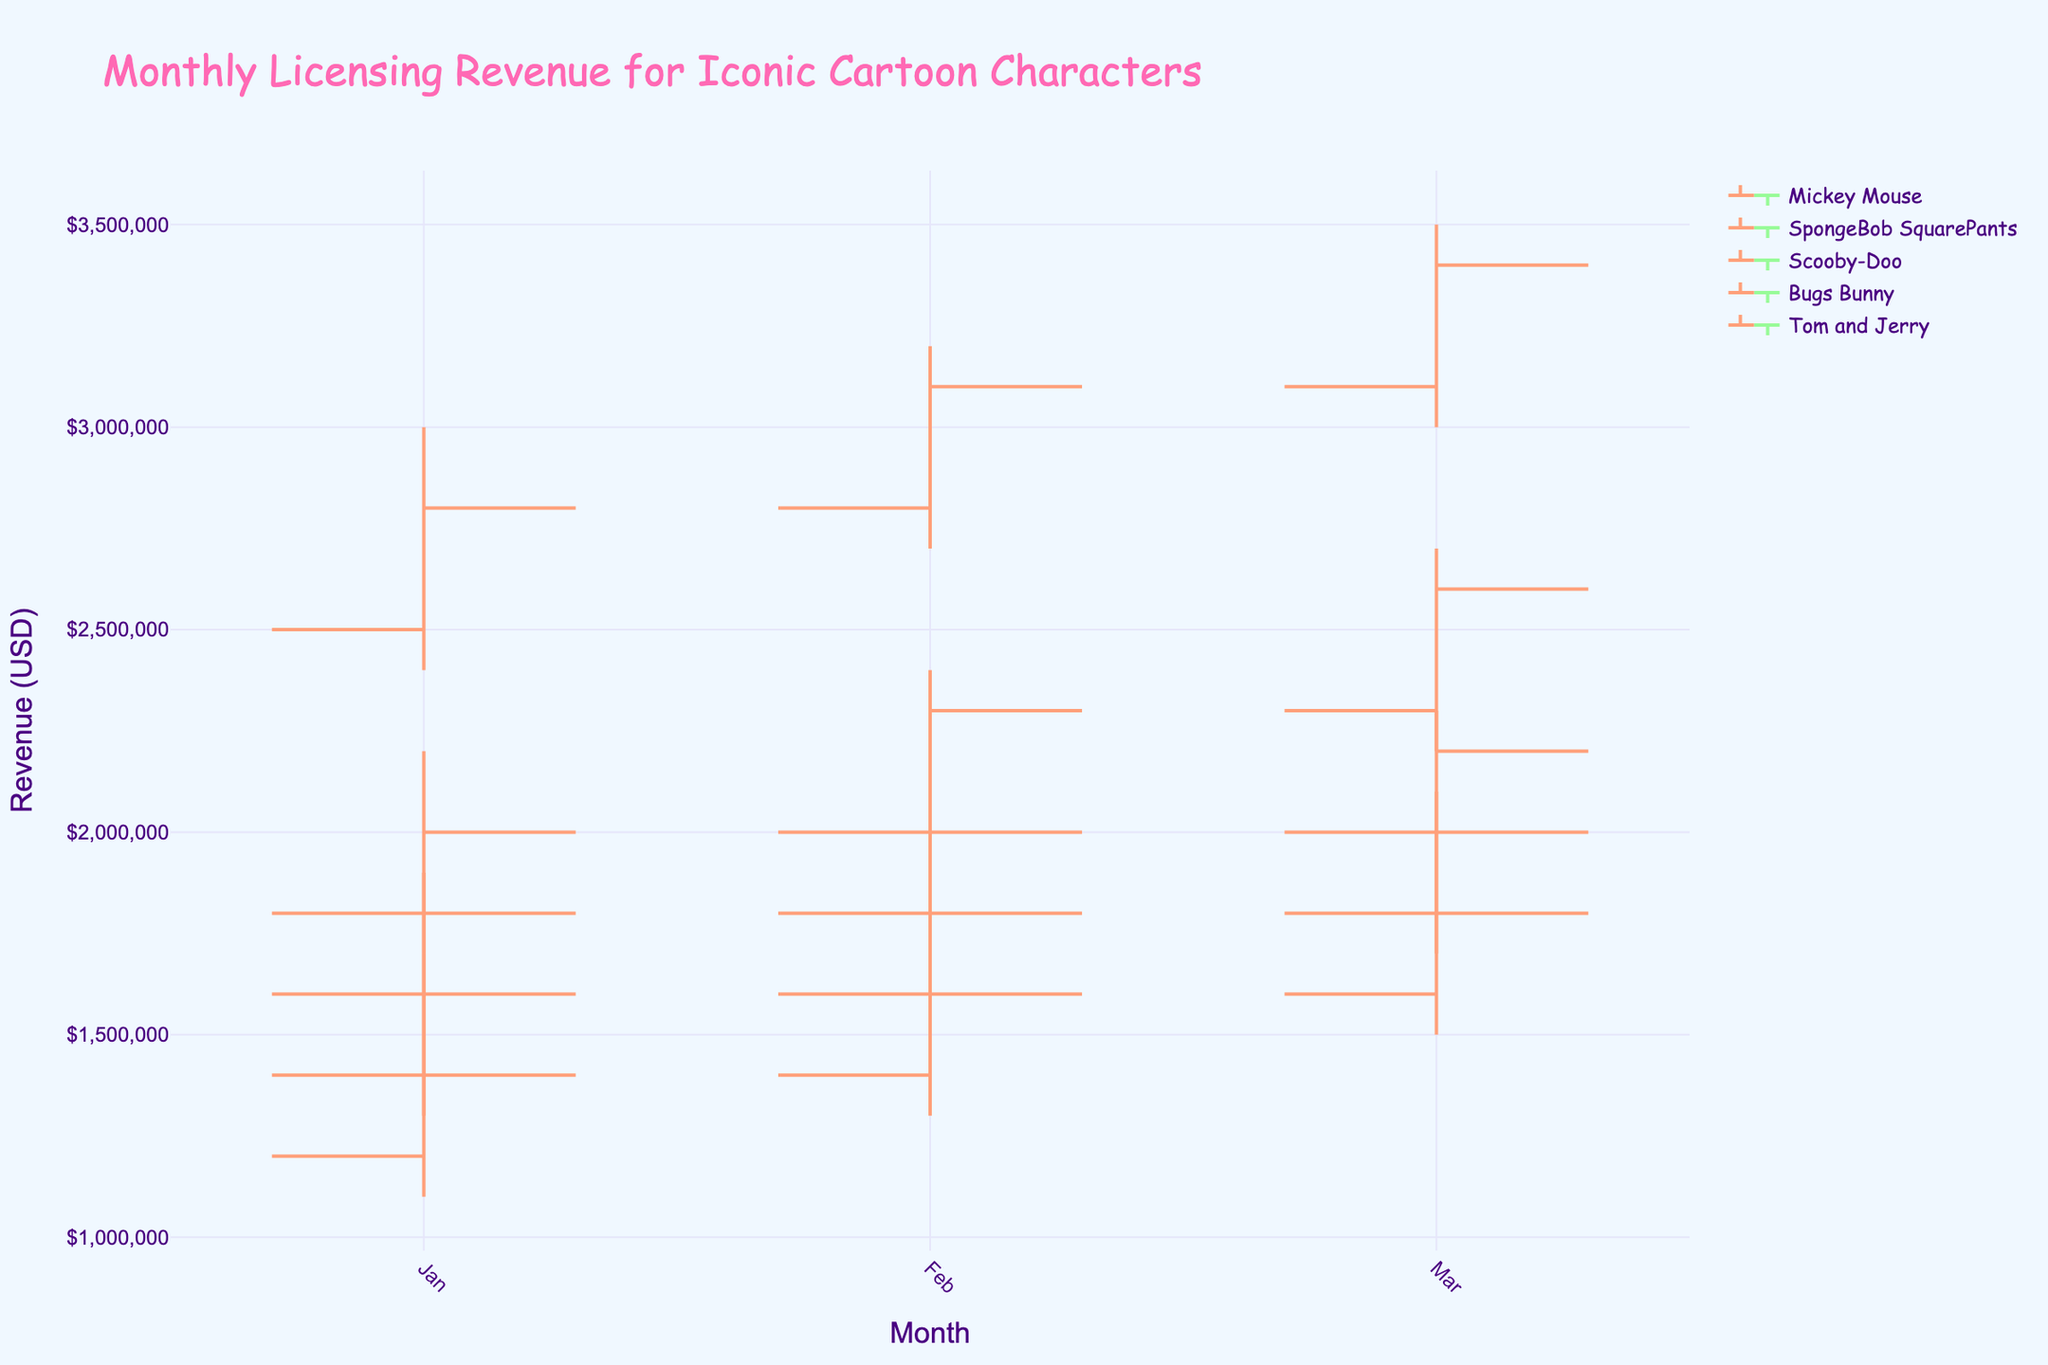What's the title of the figure? The title is usually located at the top of the figure and is explicitly displayed.
Answer: Monthly Licensing Revenue for Iconic Cartoon Characters Which character had the highest closing revenue in March? By looking at the 'Close' value for each character in March, identify the highest value among them.
Answer: Mickey Mouse What is the color used for increasing lines in the chart? Inspect the color of lines when the closing value is higher than the opening value.
Answer: Light Salmon Which character had the lowest low in February? Examine the 'Low' values for each character in February and determine which one is the lowest.
Answer: Scooby-Doo Compare the revenue growth of Mickey Mouse and SpongeBob SquarePants from January to March. Who had a higher increase? Calculate the difference between the closing revenue in March and January for both Mickey Mouse and SpongeBob SquarePants. Compare these differences.
Answer: Mickey Mouse How does the closing revenue of Scooby-Doo in March compare to that in January? Find the 'Close' values of Scooby-Doo for January and March, then compare the two values.
Answer: Higher Which month had the highest revenue range for Tom and Jerry? For Tom and Jerry, calculate the difference between 'High' and 'Low' for each month, and identify the month with the largest range.
Answer: March How did Bugs Bunny's revenue trend from January through March? Observe the 'Close' values of Bugs Bunny for the three months and identify the trend.
Answer: Increasing Among all characters, which had the second highest opening revenue in February? Identify the 'Open' values for each character in February, sort them, and find the second highest value.
Answer: Mickey Mouse 